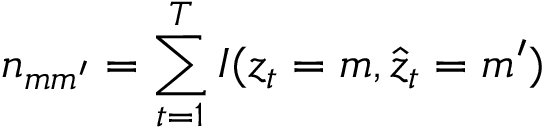<formula> <loc_0><loc_0><loc_500><loc_500>n _ { m m ^ { \prime } } = \sum _ { t = 1 } ^ { T } I ( z _ { t } = m , \hat { z } _ { t } = m ^ { \prime } )</formula> 